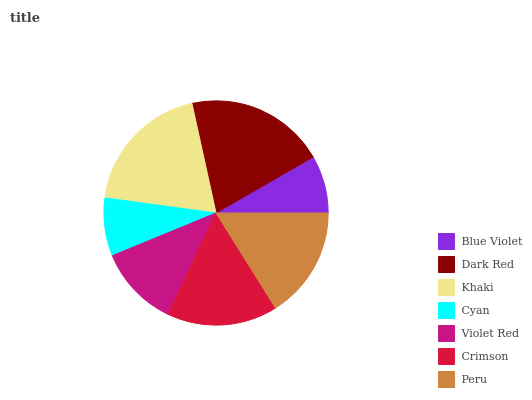Is Blue Violet the minimum?
Answer yes or no. Yes. Is Dark Red the maximum?
Answer yes or no. Yes. Is Khaki the minimum?
Answer yes or no. No. Is Khaki the maximum?
Answer yes or no. No. Is Dark Red greater than Khaki?
Answer yes or no. Yes. Is Khaki less than Dark Red?
Answer yes or no. Yes. Is Khaki greater than Dark Red?
Answer yes or no. No. Is Dark Red less than Khaki?
Answer yes or no. No. Is Crimson the high median?
Answer yes or no. Yes. Is Crimson the low median?
Answer yes or no. Yes. Is Khaki the high median?
Answer yes or no. No. Is Cyan the low median?
Answer yes or no. No. 